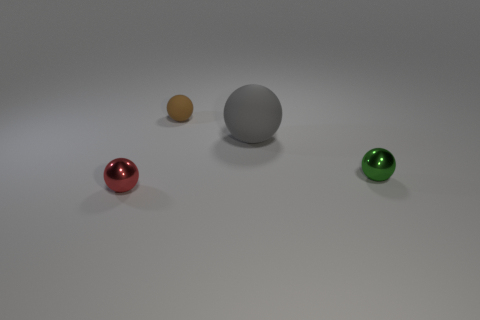Can you estimate the relative sizes of these objects in the image? While it's challenging to determine exact sizes without a reference, the objects seem to be relatively small, perhaps the size of marbles or table tennis balls. They are close in size to each other, with the gray object appearing to be the largest amongst them. 